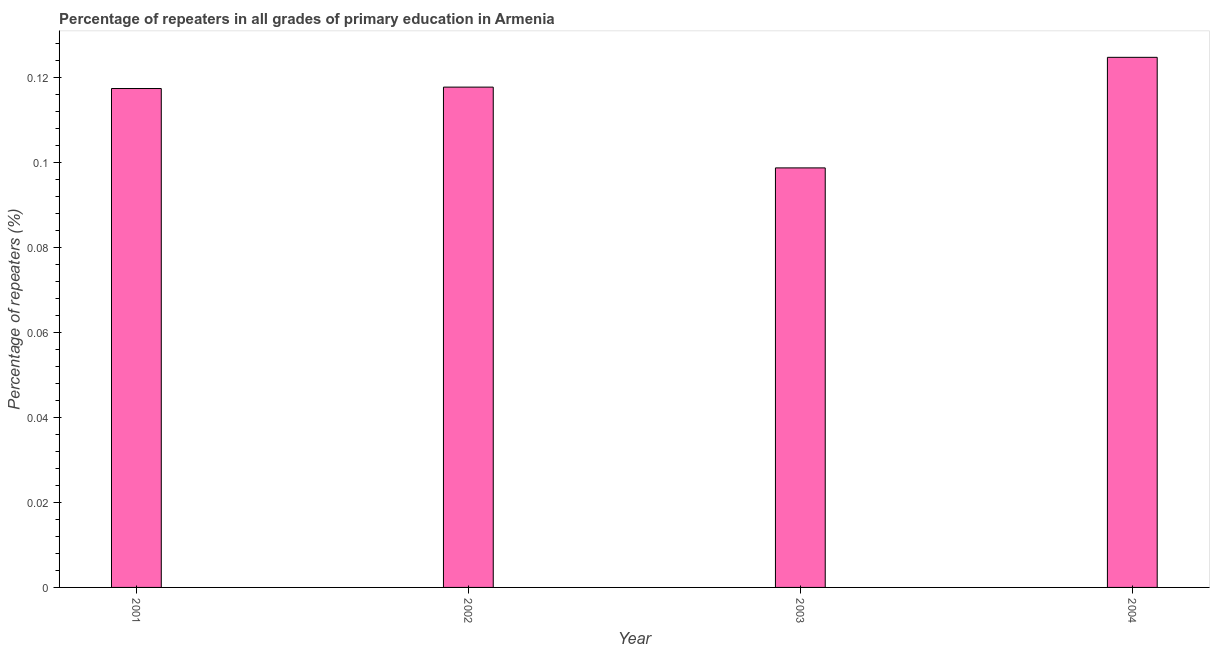Does the graph contain any zero values?
Your answer should be compact. No. Does the graph contain grids?
Offer a very short reply. No. What is the title of the graph?
Give a very brief answer. Percentage of repeaters in all grades of primary education in Armenia. What is the label or title of the X-axis?
Provide a short and direct response. Year. What is the label or title of the Y-axis?
Keep it short and to the point. Percentage of repeaters (%). What is the percentage of repeaters in primary education in 2004?
Your answer should be very brief. 0.12. Across all years, what is the maximum percentage of repeaters in primary education?
Provide a succinct answer. 0.12. Across all years, what is the minimum percentage of repeaters in primary education?
Ensure brevity in your answer.  0.1. What is the sum of the percentage of repeaters in primary education?
Make the answer very short. 0.46. What is the difference between the percentage of repeaters in primary education in 2002 and 2004?
Ensure brevity in your answer.  -0.01. What is the average percentage of repeaters in primary education per year?
Your response must be concise. 0.12. What is the median percentage of repeaters in primary education?
Your answer should be very brief. 0.12. Do a majority of the years between 2003 and 2004 (inclusive) have percentage of repeaters in primary education greater than 0.1 %?
Provide a short and direct response. No. What is the ratio of the percentage of repeaters in primary education in 2003 to that in 2004?
Your answer should be very brief. 0.79. Is the percentage of repeaters in primary education in 2003 less than that in 2004?
Ensure brevity in your answer.  Yes. Is the difference between the percentage of repeaters in primary education in 2001 and 2002 greater than the difference between any two years?
Provide a short and direct response. No. What is the difference between the highest and the second highest percentage of repeaters in primary education?
Provide a succinct answer. 0.01. Is the sum of the percentage of repeaters in primary education in 2003 and 2004 greater than the maximum percentage of repeaters in primary education across all years?
Keep it short and to the point. Yes. In how many years, is the percentage of repeaters in primary education greater than the average percentage of repeaters in primary education taken over all years?
Offer a terse response. 3. Are all the bars in the graph horizontal?
Ensure brevity in your answer.  No. How many years are there in the graph?
Your response must be concise. 4. What is the Percentage of repeaters (%) in 2001?
Provide a short and direct response. 0.12. What is the Percentage of repeaters (%) in 2002?
Provide a short and direct response. 0.12. What is the Percentage of repeaters (%) of 2003?
Keep it short and to the point. 0.1. What is the Percentage of repeaters (%) of 2004?
Your answer should be compact. 0.12. What is the difference between the Percentage of repeaters (%) in 2001 and 2002?
Your answer should be compact. -0. What is the difference between the Percentage of repeaters (%) in 2001 and 2003?
Make the answer very short. 0.02. What is the difference between the Percentage of repeaters (%) in 2001 and 2004?
Offer a very short reply. -0.01. What is the difference between the Percentage of repeaters (%) in 2002 and 2003?
Your answer should be compact. 0.02. What is the difference between the Percentage of repeaters (%) in 2002 and 2004?
Provide a succinct answer. -0.01. What is the difference between the Percentage of repeaters (%) in 2003 and 2004?
Your answer should be compact. -0.03. What is the ratio of the Percentage of repeaters (%) in 2001 to that in 2003?
Offer a very short reply. 1.19. What is the ratio of the Percentage of repeaters (%) in 2001 to that in 2004?
Provide a succinct answer. 0.94. What is the ratio of the Percentage of repeaters (%) in 2002 to that in 2003?
Your answer should be very brief. 1.19. What is the ratio of the Percentage of repeaters (%) in 2002 to that in 2004?
Your answer should be compact. 0.94. What is the ratio of the Percentage of repeaters (%) in 2003 to that in 2004?
Offer a terse response. 0.79. 